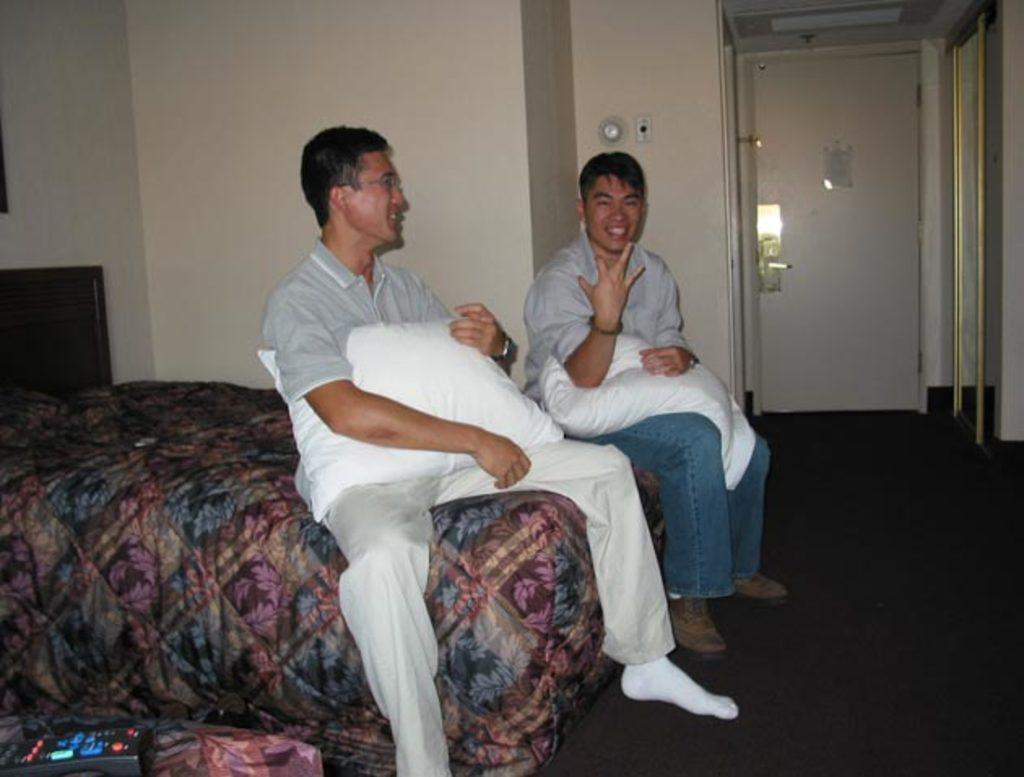How many people are in the image? There are two persons in the image. What are the two persons doing in the image? The two persons are sitting on a bed and holding a pillow. What can be seen in the background of the image? There is a bed and a door in the background of the image. What type of lipstick is the person wearing in the image? There is no person wearing lipstick in the image, as it features two persons sitting on a bed and holding a pillow. 